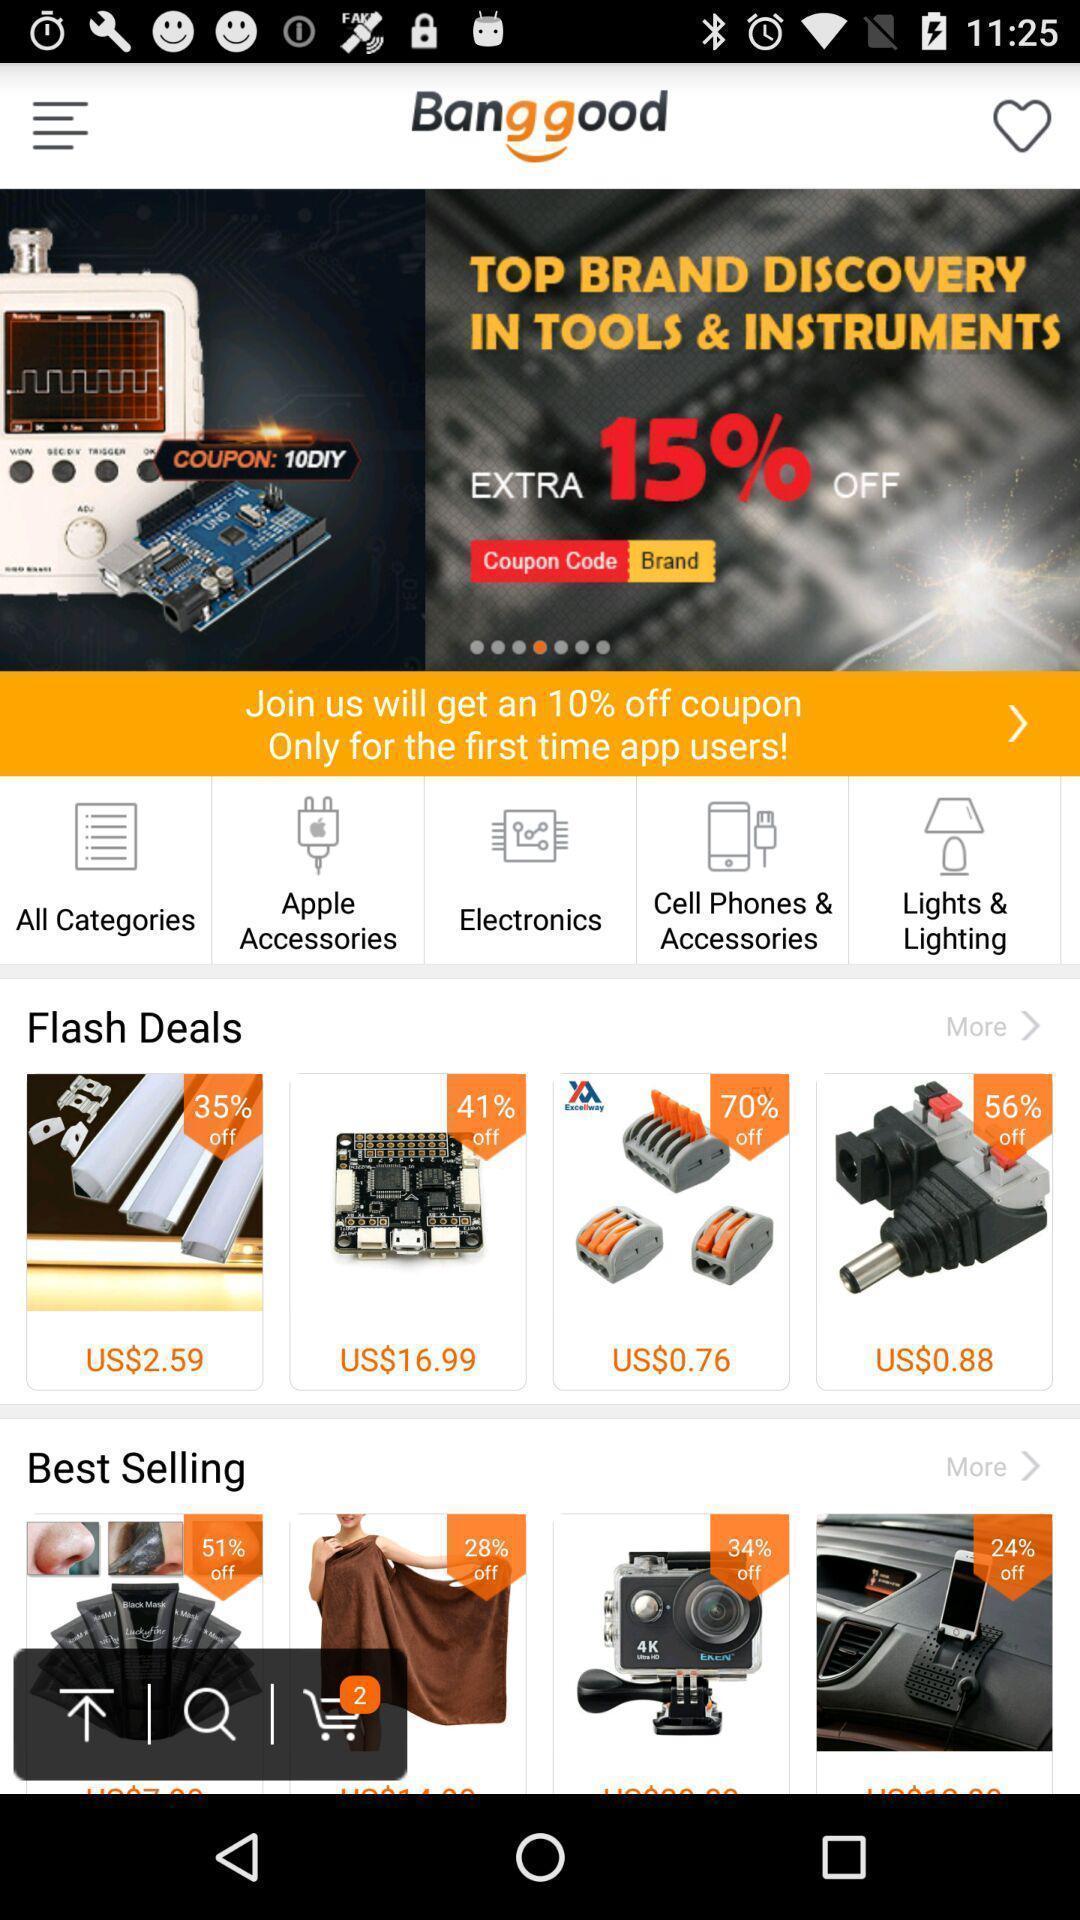Describe this image in words. Screen shows multiple options in a shopping application. 